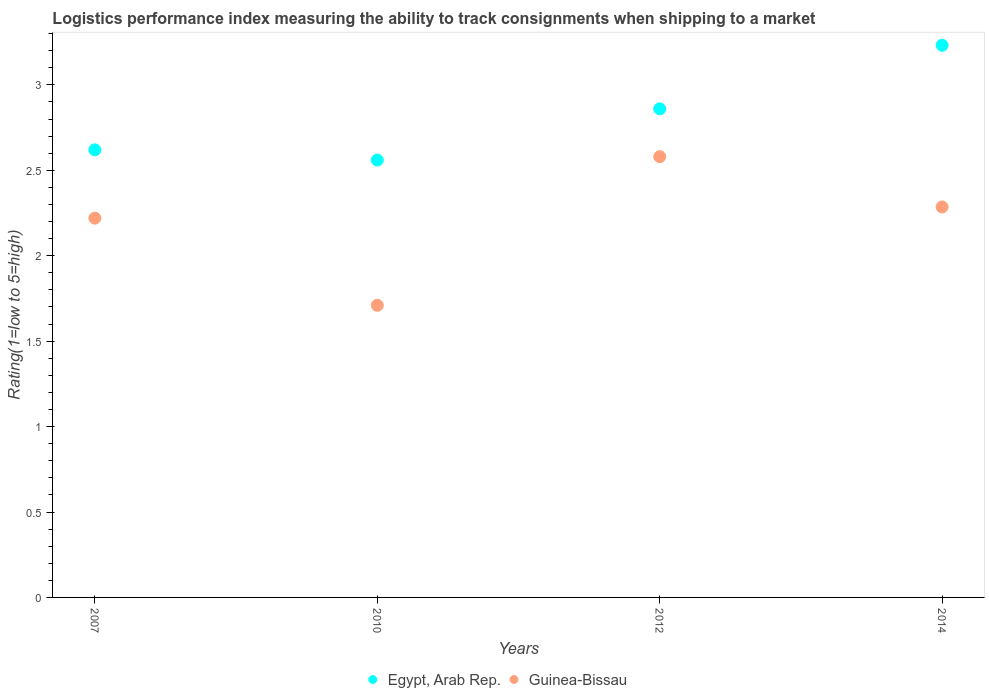How many different coloured dotlines are there?
Ensure brevity in your answer.  2. Is the number of dotlines equal to the number of legend labels?
Provide a short and direct response. Yes. What is the Logistic performance index in Guinea-Bissau in 2010?
Provide a succinct answer. 1.71. Across all years, what is the maximum Logistic performance index in Egypt, Arab Rep.?
Give a very brief answer. 3.23. Across all years, what is the minimum Logistic performance index in Egypt, Arab Rep.?
Make the answer very short. 2.56. In which year was the Logistic performance index in Egypt, Arab Rep. maximum?
Your response must be concise. 2014. What is the total Logistic performance index in Egypt, Arab Rep. in the graph?
Offer a very short reply. 11.27. What is the difference between the Logistic performance index in Guinea-Bissau in 2010 and that in 2014?
Your answer should be compact. -0.58. What is the difference between the Logistic performance index in Egypt, Arab Rep. in 2014 and the Logistic performance index in Guinea-Bissau in 2012?
Offer a very short reply. 0.65. What is the average Logistic performance index in Egypt, Arab Rep. per year?
Your answer should be very brief. 2.82. In the year 2012, what is the difference between the Logistic performance index in Egypt, Arab Rep. and Logistic performance index in Guinea-Bissau?
Give a very brief answer. 0.28. In how many years, is the Logistic performance index in Egypt, Arab Rep. greater than 2.3?
Provide a succinct answer. 4. What is the ratio of the Logistic performance index in Egypt, Arab Rep. in 2010 to that in 2012?
Keep it short and to the point. 0.9. What is the difference between the highest and the second highest Logistic performance index in Guinea-Bissau?
Your answer should be very brief. 0.29. What is the difference between the highest and the lowest Logistic performance index in Guinea-Bissau?
Give a very brief answer. 0.87. In how many years, is the Logistic performance index in Guinea-Bissau greater than the average Logistic performance index in Guinea-Bissau taken over all years?
Provide a succinct answer. 3. Is the sum of the Logistic performance index in Egypt, Arab Rep. in 2007 and 2010 greater than the maximum Logistic performance index in Guinea-Bissau across all years?
Ensure brevity in your answer.  Yes. Does the Logistic performance index in Egypt, Arab Rep. monotonically increase over the years?
Your answer should be compact. No. Is the Logistic performance index in Egypt, Arab Rep. strictly greater than the Logistic performance index in Guinea-Bissau over the years?
Your answer should be compact. Yes. Is the Logistic performance index in Guinea-Bissau strictly less than the Logistic performance index in Egypt, Arab Rep. over the years?
Your response must be concise. Yes. How many years are there in the graph?
Your response must be concise. 4. Does the graph contain any zero values?
Offer a very short reply. No. How many legend labels are there?
Make the answer very short. 2. What is the title of the graph?
Keep it short and to the point. Logistics performance index measuring the ability to track consignments when shipping to a market. What is the label or title of the X-axis?
Your answer should be very brief. Years. What is the label or title of the Y-axis?
Offer a terse response. Rating(1=low to 5=high). What is the Rating(1=low to 5=high) in Egypt, Arab Rep. in 2007?
Provide a succinct answer. 2.62. What is the Rating(1=low to 5=high) of Guinea-Bissau in 2007?
Ensure brevity in your answer.  2.22. What is the Rating(1=low to 5=high) in Egypt, Arab Rep. in 2010?
Keep it short and to the point. 2.56. What is the Rating(1=low to 5=high) in Guinea-Bissau in 2010?
Give a very brief answer. 1.71. What is the Rating(1=low to 5=high) in Egypt, Arab Rep. in 2012?
Make the answer very short. 2.86. What is the Rating(1=low to 5=high) in Guinea-Bissau in 2012?
Keep it short and to the point. 2.58. What is the Rating(1=low to 5=high) in Egypt, Arab Rep. in 2014?
Your answer should be compact. 3.23. What is the Rating(1=low to 5=high) of Guinea-Bissau in 2014?
Offer a very short reply. 2.29. Across all years, what is the maximum Rating(1=low to 5=high) of Egypt, Arab Rep.?
Your answer should be very brief. 3.23. Across all years, what is the maximum Rating(1=low to 5=high) in Guinea-Bissau?
Your response must be concise. 2.58. Across all years, what is the minimum Rating(1=low to 5=high) of Egypt, Arab Rep.?
Your response must be concise. 2.56. Across all years, what is the minimum Rating(1=low to 5=high) in Guinea-Bissau?
Your response must be concise. 1.71. What is the total Rating(1=low to 5=high) of Egypt, Arab Rep. in the graph?
Offer a very short reply. 11.27. What is the total Rating(1=low to 5=high) in Guinea-Bissau in the graph?
Provide a short and direct response. 8.8. What is the difference between the Rating(1=low to 5=high) in Egypt, Arab Rep. in 2007 and that in 2010?
Make the answer very short. 0.06. What is the difference between the Rating(1=low to 5=high) of Guinea-Bissau in 2007 and that in 2010?
Offer a terse response. 0.51. What is the difference between the Rating(1=low to 5=high) in Egypt, Arab Rep. in 2007 and that in 2012?
Offer a terse response. -0.24. What is the difference between the Rating(1=low to 5=high) in Guinea-Bissau in 2007 and that in 2012?
Provide a succinct answer. -0.36. What is the difference between the Rating(1=low to 5=high) of Egypt, Arab Rep. in 2007 and that in 2014?
Offer a terse response. -0.61. What is the difference between the Rating(1=low to 5=high) of Guinea-Bissau in 2007 and that in 2014?
Your answer should be very brief. -0.07. What is the difference between the Rating(1=low to 5=high) in Guinea-Bissau in 2010 and that in 2012?
Give a very brief answer. -0.87. What is the difference between the Rating(1=low to 5=high) in Egypt, Arab Rep. in 2010 and that in 2014?
Offer a terse response. -0.67. What is the difference between the Rating(1=low to 5=high) of Guinea-Bissau in 2010 and that in 2014?
Offer a very short reply. -0.58. What is the difference between the Rating(1=low to 5=high) of Egypt, Arab Rep. in 2012 and that in 2014?
Ensure brevity in your answer.  -0.37. What is the difference between the Rating(1=low to 5=high) in Guinea-Bissau in 2012 and that in 2014?
Make the answer very short. 0.29. What is the difference between the Rating(1=low to 5=high) of Egypt, Arab Rep. in 2007 and the Rating(1=low to 5=high) of Guinea-Bissau in 2010?
Ensure brevity in your answer.  0.91. What is the difference between the Rating(1=low to 5=high) in Egypt, Arab Rep. in 2007 and the Rating(1=low to 5=high) in Guinea-Bissau in 2012?
Give a very brief answer. 0.04. What is the difference between the Rating(1=low to 5=high) in Egypt, Arab Rep. in 2007 and the Rating(1=low to 5=high) in Guinea-Bissau in 2014?
Provide a short and direct response. 0.33. What is the difference between the Rating(1=low to 5=high) in Egypt, Arab Rep. in 2010 and the Rating(1=low to 5=high) in Guinea-Bissau in 2012?
Ensure brevity in your answer.  -0.02. What is the difference between the Rating(1=low to 5=high) in Egypt, Arab Rep. in 2010 and the Rating(1=low to 5=high) in Guinea-Bissau in 2014?
Offer a terse response. 0.27. What is the difference between the Rating(1=low to 5=high) in Egypt, Arab Rep. in 2012 and the Rating(1=low to 5=high) in Guinea-Bissau in 2014?
Give a very brief answer. 0.57. What is the average Rating(1=low to 5=high) of Egypt, Arab Rep. per year?
Your answer should be compact. 2.82. What is the average Rating(1=low to 5=high) in Guinea-Bissau per year?
Your answer should be compact. 2.2. In the year 2012, what is the difference between the Rating(1=low to 5=high) of Egypt, Arab Rep. and Rating(1=low to 5=high) of Guinea-Bissau?
Offer a terse response. 0.28. In the year 2014, what is the difference between the Rating(1=low to 5=high) in Egypt, Arab Rep. and Rating(1=low to 5=high) in Guinea-Bissau?
Your answer should be very brief. 0.95. What is the ratio of the Rating(1=low to 5=high) in Egypt, Arab Rep. in 2007 to that in 2010?
Make the answer very short. 1.02. What is the ratio of the Rating(1=low to 5=high) in Guinea-Bissau in 2007 to that in 2010?
Your answer should be compact. 1.3. What is the ratio of the Rating(1=low to 5=high) of Egypt, Arab Rep. in 2007 to that in 2012?
Provide a succinct answer. 0.92. What is the ratio of the Rating(1=low to 5=high) of Guinea-Bissau in 2007 to that in 2012?
Your response must be concise. 0.86. What is the ratio of the Rating(1=low to 5=high) in Egypt, Arab Rep. in 2007 to that in 2014?
Your answer should be compact. 0.81. What is the ratio of the Rating(1=low to 5=high) of Guinea-Bissau in 2007 to that in 2014?
Give a very brief answer. 0.97. What is the ratio of the Rating(1=low to 5=high) in Egypt, Arab Rep. in 2010 to that in 2012?
Your response must be concise. 0.9. What is the ratio of the Rating(1=low to 5=high) in Guinea-Bissau in 2010 to that in 2012?
Provide a succinct answer. 0.66. What is the ratio of the Rating(1=low to 5=high) in Egypt, Arab Rep. in 2010 to that in 2014?
Your response must be concise. 0.79. What is the ratio of the Rating(1=low to 5=high) in Guinea-Bissau in 2010 to that in 2014?
Provide a short and direct response. 0.75. What is the ratio of the Rating(1=low to 5=high) in Egypt, Arab Rep. in 2012 to that in 2014?
Ensure brevity in your answer.  0.88. What is the ratio of the Rating(1=low to 5=high) in Guinea-Bissau in 2012 to that in 2014?
Offer a terse response. 1.13. What is the difference between the highest and the second highest Rating(1=low to 5=high) of Egypt, Arab Rep.?
Offer a terse response. 0.37. What is the difference between the highest and the second highest Rating(1=low to 5=high) of Guinea-Bissau?
Your answer should be compact. 0.29. What is the difference between the highest and the lowest Rating(1=low to 5=high) in Egypt, Arab Rep.?
Offer a terse response. 0.67. What is the difference between the highest and the lowest Rating(1=low to 5=high) in Guinea-Bissau?
Give a very brief answer. 0.87. 